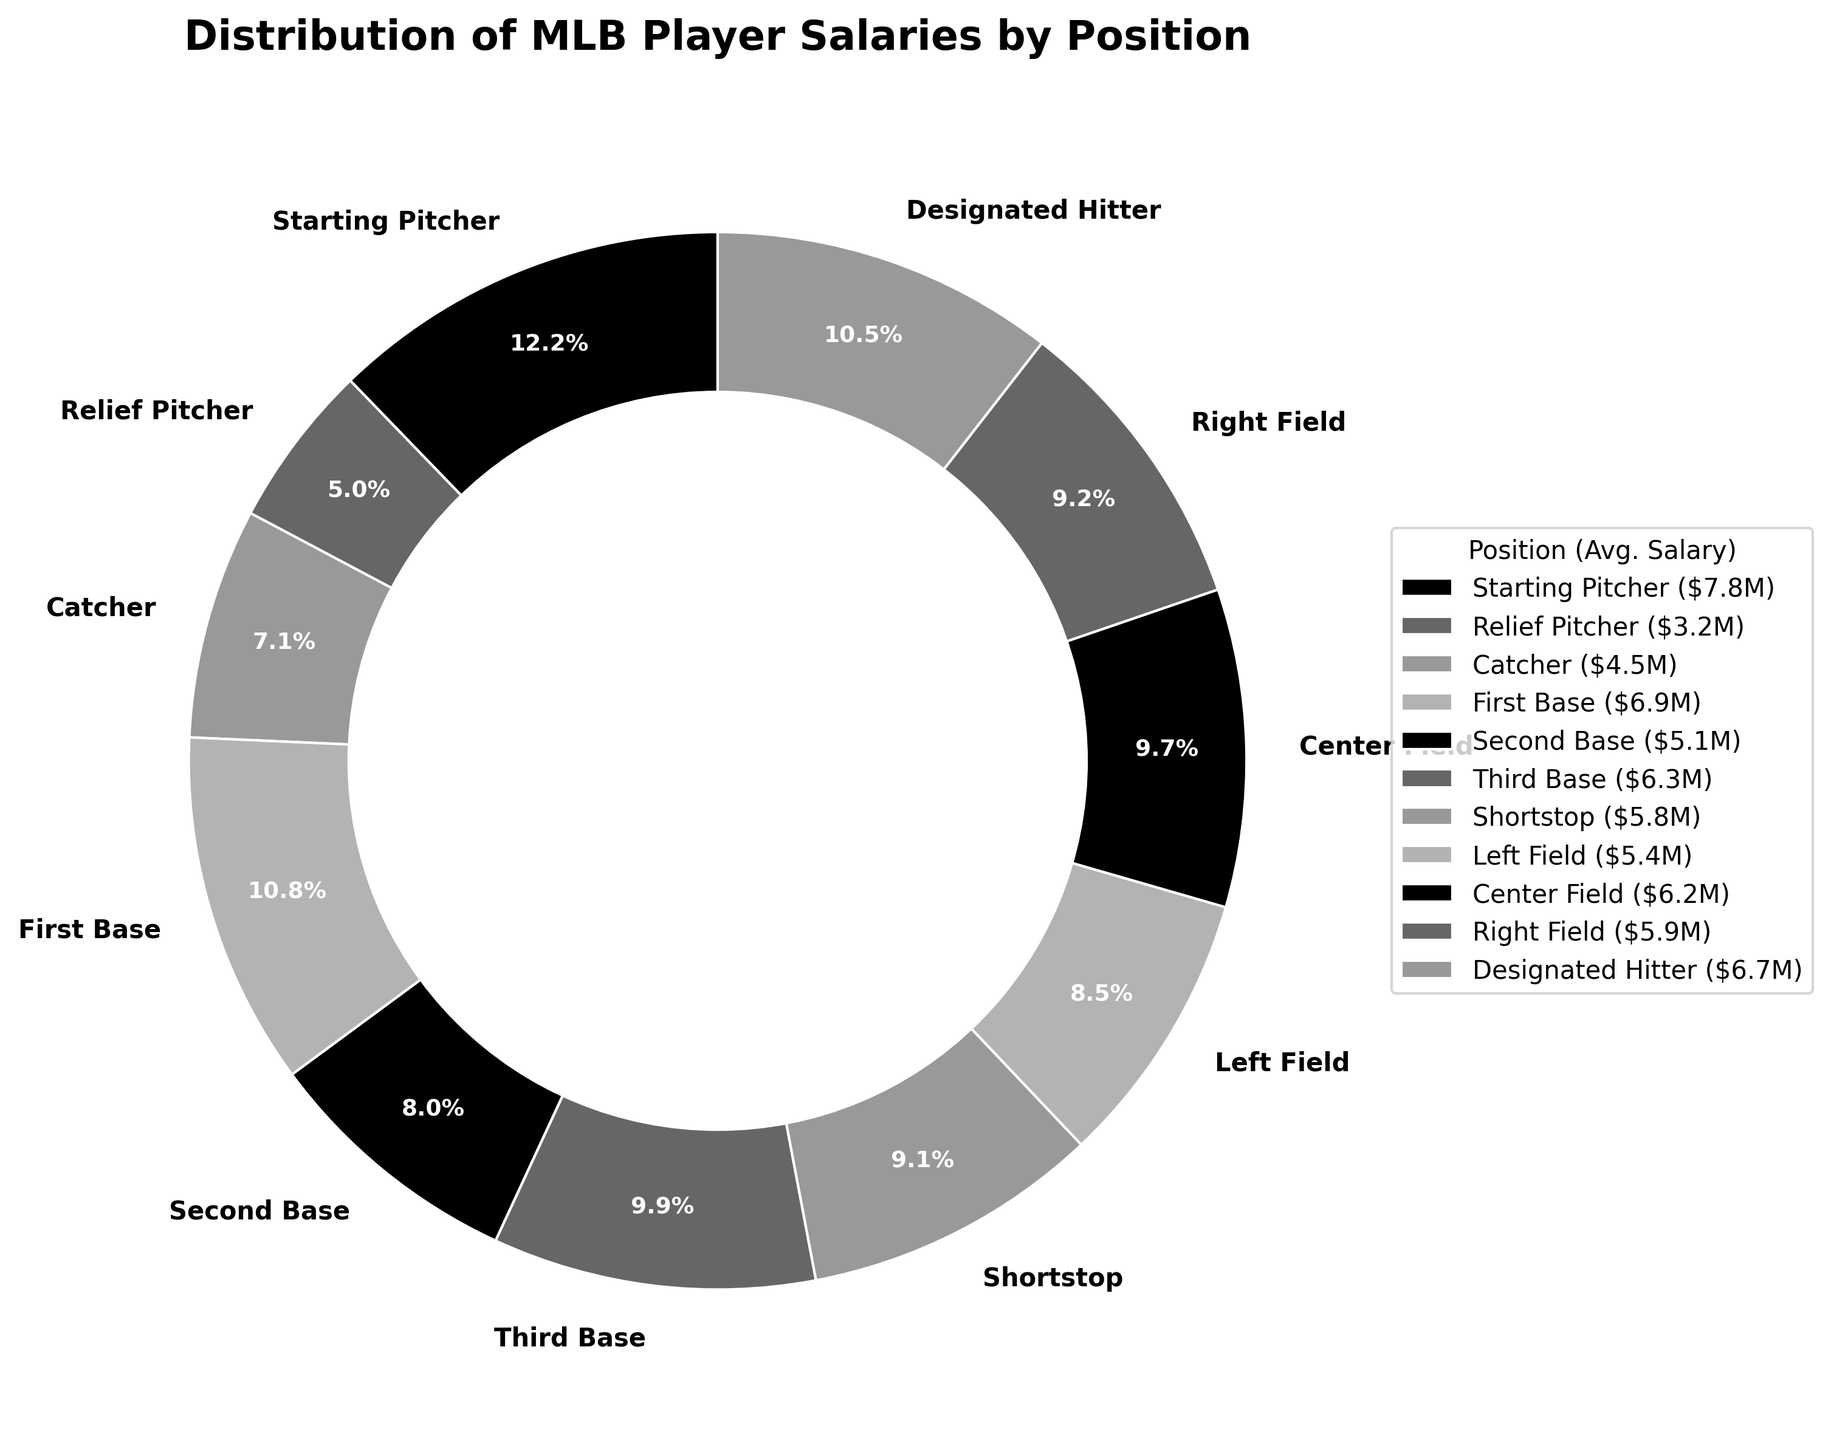Which position has the highest average salary? The highest average salary can be identified by looking at the segment of the pie chart with the largest percentage. The "Starting Pitcher" position has the highest average salary of $7.8 million.
Answer: Starting Pitcher Which position has the lowest average salary? The lowest average salary can be identified by looking at the segment of the pie chart with the smallest percentage. The "Relief Pitcher" position has the lowest average salary of $3.2 million.
Answer: Relief Pitcher How much more is the average salary of a First Base player compared to a Relief Pitcher? Find the difference between the average salaries of these positions: $6.9 million (First Base) - $3.2 million (Relief Pitcher) = $3.7 million.
Answer: $3.7 million What is the combined average salary of players in First Base and Designated Hitter positions? Add the average salaries of these positions: $6.9 million (First Base) + $6.7 million (Designated Hitter) = $13.6 million.
Answer: $13.6 million Which three positions have the highest average salaries? Observe the top three segments in terms of size to identify their labels. "Starting Pitcher" ($7.8M), "First Base" ($6.9M), and "Designated Hitter" ($6.7M) are the positions with the highest average salaries.
Answer: Starting Pitcher, First Base, Designated Hitter Is the average salary of a Third Base player higher or lower than that of a Right Field player? Compare their average salaries directly: Third Base is $6.3 million, and Right Field is $5.9 million. Third Base has a higher average salary.
Answer: Higher What is the average salary for middle field positions (Second Base, Shortstop, Center Field)? Sum their salaries and then divide by 3: ($5.1M + $5.8M + $6.2M)/3 = $17.1M/3 = $5.7 million.
Answer: $5.7 million Which position has an average salary closest to $5 million? Look at the segments and find the position that has an average salary nearest to $5 million. The "Second Base" position has an average salary of $5.1 million, which is closest to $5 million.
Answer: Second Base 